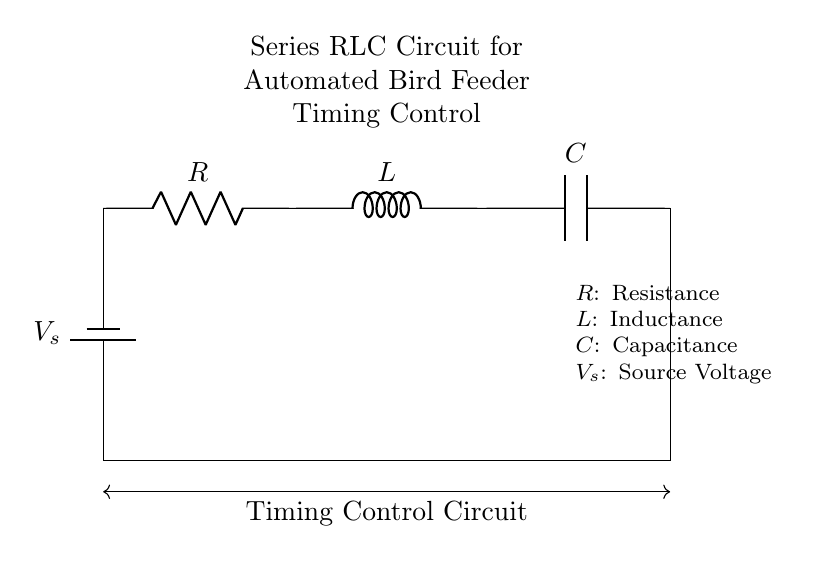What is the series configuration in this circuit? The circuit diagram shows components connected in a single path, meaning the current flows through each component one after the other. This is characteristic of a series configuration, confirming the arrangement of the resistor, inductor, and capacitor.
Answer: Series What are the components labeled in the circuit? In the circuit, the components are labeled as a resistor (R), an inductor (L), and a capacitor (C). Each component has its symbol and designation clearly indicated in the diagram to identify their roles within the circuit.
Answer: R, L, C What does the voltage source represent in this diagram? The voltage source, labeled as V_s, represents the electrical energy driving the current through the circuit. It is the supply voltage required to charge the capacitor, energize the inductor, and produce a current through the resistor.
Answer: V_s How do changes in capacitance affect the timing in this circuit? The timing in an RLC circuit is predominantly influenced by the capacitor's charge and discharge rate, which is affected by its capacitance value. A larger capacitance increases the time constant, leading to longer timing intervals for the automated feeder compared to a smaller capacitance that would result in quicker cycles.
Answer: Longer intervals What is the role of the resistor in this timing circuit? The resistor in the circuit dissipates energy, which affects the overall timing of the charge and discharge of the capacitor. It introduces a time delay based on its resistance value and contributes to the damping of oscillations within the RLC circuit, determining how quickly the system responds to changes.
Answer: Damping What is the function of the inductor in the circuit? The inductor stores energy in its magnetic field when current passes through it and reacts to changes in current flow, contributing to the timing control by influencing how quickly the circuit responds to the voltage changes. Its presence creates inductive reactance, which plays a key role in the circuit dynamics.
Answer: Energy storage How would increased resistance in the circuit affect the timing control? Increasing resistance in the circuit would reduce the current flow and, consequently, the rate at which the capacitor charges or discharges. This would lead to an increased time constant, thus prolonging the timing intervals in the automated bird feeder operation. It effectively makes the timing slower.
Answer: Increased timing 